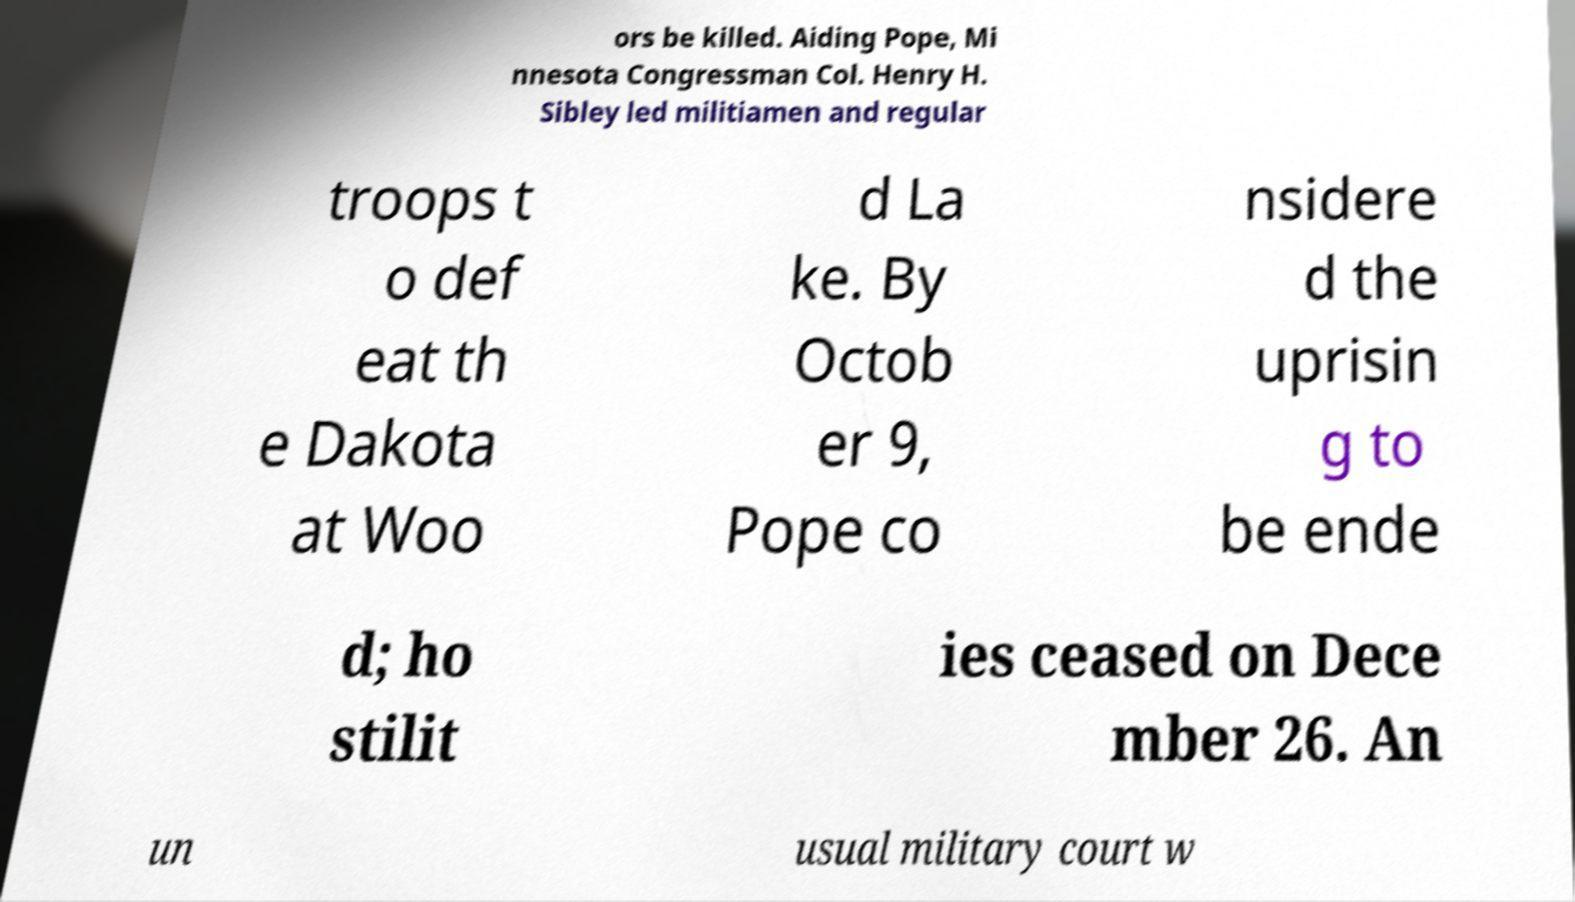For documentation purposes, I need the text within this image transcribed. Could you provide that? ors be killed. Aiding Pope, Mi nnesota Congressman Col. Henry H. Sibley led militiamen and regular troops t o def eat th e Dakota at Woo d La ke. By Octob er 9, Pope co nsidere d the uprisin g to be ende d; ho stilit ies ceased on Dece mber 26. An un usual military court w 